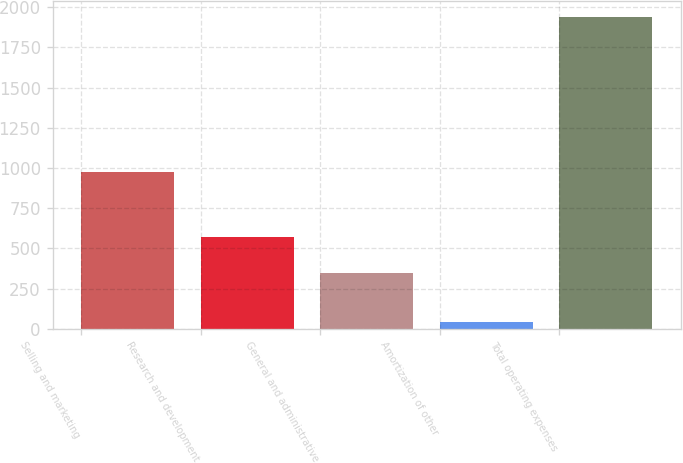Convert chart. <chart><loc_0><loc_0><loc_500><loc_500><bar_chart><fcel>Selling and marketing<fcel>Research and development<fcel>General and administrative<fcel>Amortization of other<fcel>Total operating expenses<nl><fcel>976<fcel>573<fcel>348<fcel>42<fcel>1939<nl></chart> 